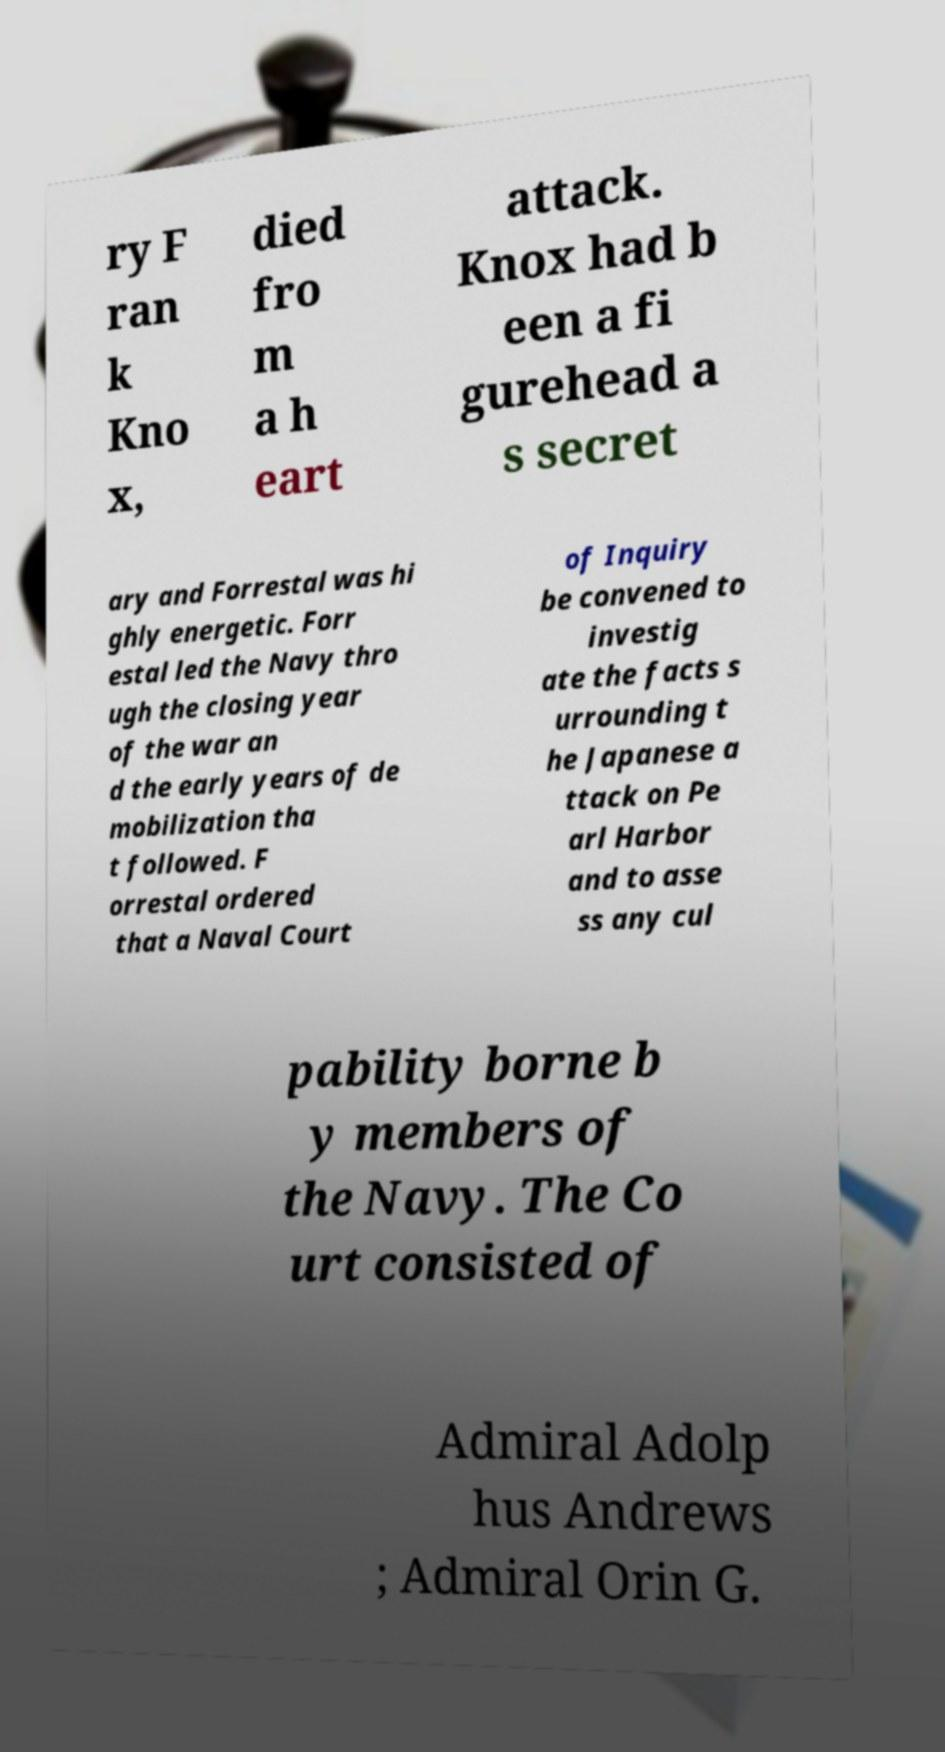What messages or text are displayed in this image? I need them in a readable, typed format. ry F ran k Kno x, died fro m a h eart attack. Knox had b een a fi gurehead a s secret ary and Forrestal was hi ghly energetic. Forr estal led the Navy thro ugh the closing year of the war an d the early years of de mobilization tha t followed. F orrestal ordered that a Naval Court of Inquiry be convened to investig ate the facts s urrounding t he Japanese a ttack on Pe arl Harbor and to asse ss any cul pability borne b y members of the Navy. The Co urt consisted of Admiral Adolp hus Andrews ; Admiral Orin G. 